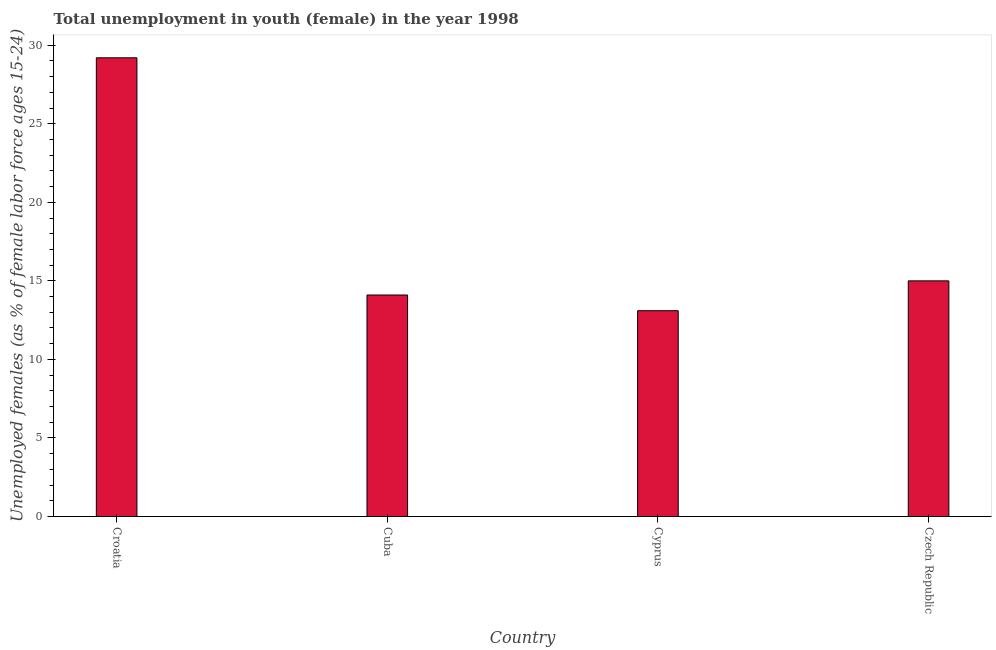Does the graph contain grids?
Offer a very short reply. No. What is the title of the graph?
Offer a very short reply. Total unemployment in youth (female) in the year 1998. What is the label or title of the Y-axis?
Give a very brief answer. Unemployed females (as % of female labor force ages 15-24). What is the unemployed female youth population in Croatia?
Give a very brief answer. 29.2. Across all countries, what is the maximum unemployed female youth population?
Provide a succinct answer. 29.2. Across all countries, what is the minimum unemployed female youth population?
Your response must be concise. 13.1. In which country was the unemployed female youth population maximum?
Keep it short and to the point. Croatia. In which country was the unemployed female youth population minimum?
Keep it short and to the point. Cyprus. What is the sum of the unemployed female youth population?
Provide a short and direct response. 71.4. What is the average unemployed female youth population per country?
Provide a short and direct response. 17.85. What is the median unemployed female youth population?
Give a very brief answer. 14.55. In how many countries, is the unemployed female youth population greater than 24 %?
Provide a succinct answer. 1. What is the ratio of the unemployed female youth population in Croatia to that in Cyprus?
Offer a very short reply. 2.23. Is the unemployed female youth population in Croatia less than that in Cuba?
Give a very brief answer. No. What is the difference between the highest and the second highest unemployed female youth population?
Ensure brevity in your answer.  14.2. What is the difference between the highest and the lowest unemployed female youth population?
Ensure brevity in your answer.  16.1. How many bars are there?
Provide a succinct answer. 4. Are the values on the major ticks of Y-axis written in scientific E-notation?
Give a very brief answer. No. What is the Unemployed females (as % of female labor force ages 15-24) in Croatia?
Your response must be concise. 29.2. What is the Unemployed females (as % of female labor force ages 15-24) of Cuba?
Make the answer very short. 14.1. What is the Unemployed females (as % of female labor force ages 15-24) of Cyprus?
Keep it short and to the point. 13.1. What is the difference between the Unemployed females (as % of female labor force ages 15-24) in Croatia and Cuba?
Ensure brevity in your answer.  15.1. What is the difference between the Unemployed females (as % of female labor force ages 15-24) in Croatia and Cyprus?
Offer a terse response. 16.1. What is the difference between the Unemployed females (as % of female labor force ages 15-24) in Cuba and Czech Republic?
Give a very brief answer. -0.9. What is the difference between the Unemployed females (as % of female labor force ages 15-24) in Cyprus and Czech Republic?
Keep it short and to the point. -1.9. What is the ratio of the Unemployed females (as % of female labor force ages 15-24) in Croatia to that in Cuba?
Offer a very short reply. 2.07. What is the ratio of the Unemployed females (as % of female labor force ages 15-24) in Croatia to that in Cyprus?
Offer a very short reply. 2.23. What is the ratio of the Unemployed females (as % of female labor force ages 15-24) in Croatia to that in Czech Republic?
Provide a succinct answer. 1.95. What is the ratio of the Unemployed females (as % of female labor force ages 15-24) in Cuba to that in Cyprus?
Keep it short and to the point. 1.08. What is the ratio of the Unemployed females (as % of female labor force ages 15-24) in Cyprus to that in Czech Republic?
Your answer should be compact. 0.87. 